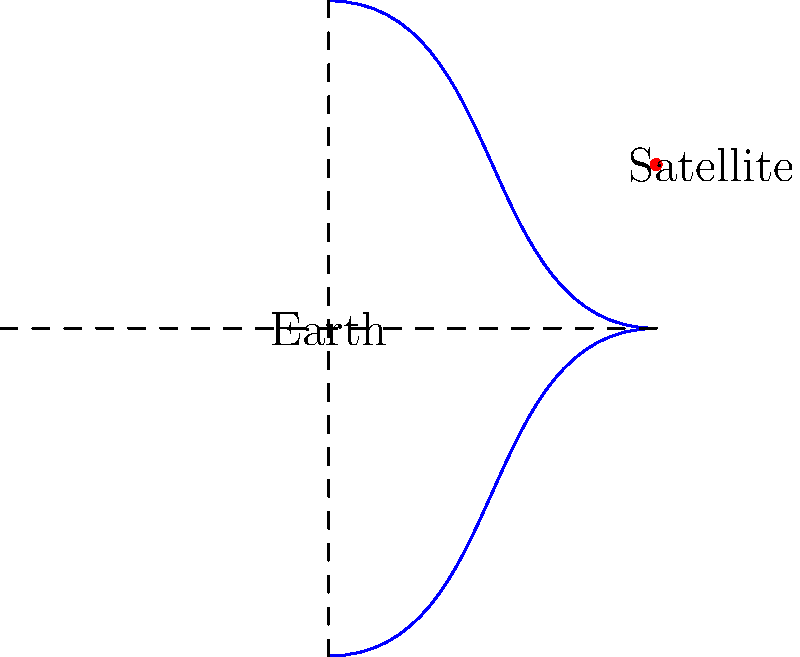As an urban farmer interested in sustainable greenhouse construction, you're curious about the satellites that provide crucial weather and climate data for your crops. These satellites typically orbit in a geostationary orbit. If a weather satellite is positioned at an altitude of 35,786 km above the Earth's surface, what is its orbital period in hours? To solve this problem, we'll use Kepler's Third Law of Planetary Motion, which applies to satellite orbits as well. The steps are as follows:

1. Kepler's Third Law states that $T^2 \propto a^3$, where $T$ is the orbital period and $a$ is the semi-major axis of the orbit.

2. For a circular orbit (which geostationary orbits are), the semi-major axis is equal to the radius of the orbit.

3. The radius of the orbit is the sum of the Earth's radius and the satellite's altitude:
   $a = R_{Earth} + h = 6,371 \text{ km} + 35,786 \text{ km} = 42,157 \text{ km}$

4. The proportionality constant in Kepler's Third Law for objects orbiting Earth is:
   $\frac{T^2}{a^3} = \frac{(24 \text{ hours})^2}{(42,164 \text{ km})^3}$

5. Substituting our values:
   $\frac{T^2}{(42,157)^3} = \frac{(24)^2}{(42,164)^3}$

6. Solving for $T$:
   $T^2 = \frac{(24)^2 \cdot (42,157)^3}{(42,164)^3} = 575.96$

7. Taking the square root:
   $T = \sqrt{575.96} = 24.00 \text{ hours}$

The orbital period is approximately 24 hours, which is why these satellites appear stationary from Earth's perspective.
Answer: 24 hours 